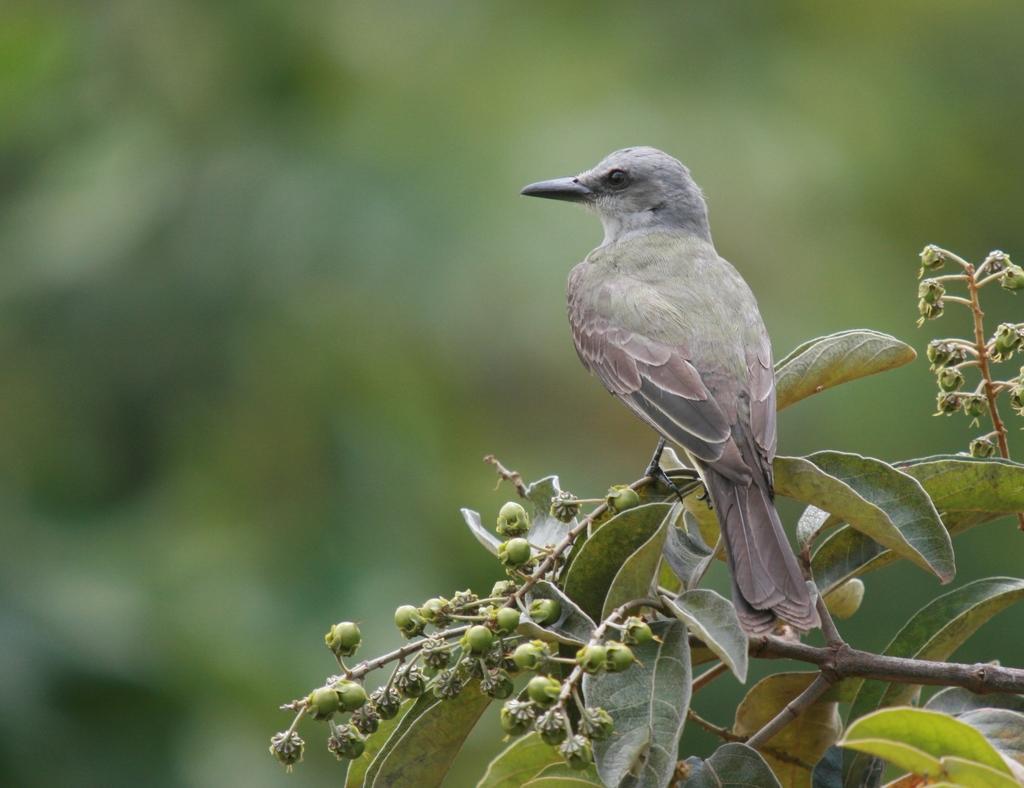In one or two sentences, can you explain what this image depicts? In this image I can see the bird sitting on the plant. The bird is in ash and grey color. I can see some buds to the plant. And there is a blurred background. 